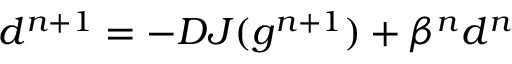<formula> <loc_0><loc_0><loc_500><loc_500>d ^ { n + 1 } = - D J ( g ^ { n + 1 } ) + \beta ^ { n } d ^ { n }</formula> 